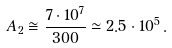Convert formula to latex. <formula><loc_0><loc_0><loc_500><loc_500>A _ { 2 } \cong \frac { 7 \cdot 1 0 ^ { 7 } } { 3 0 0 } \simeq 2 . 5 \cdot 1 0 ^ { 5 } \, .</formula> 